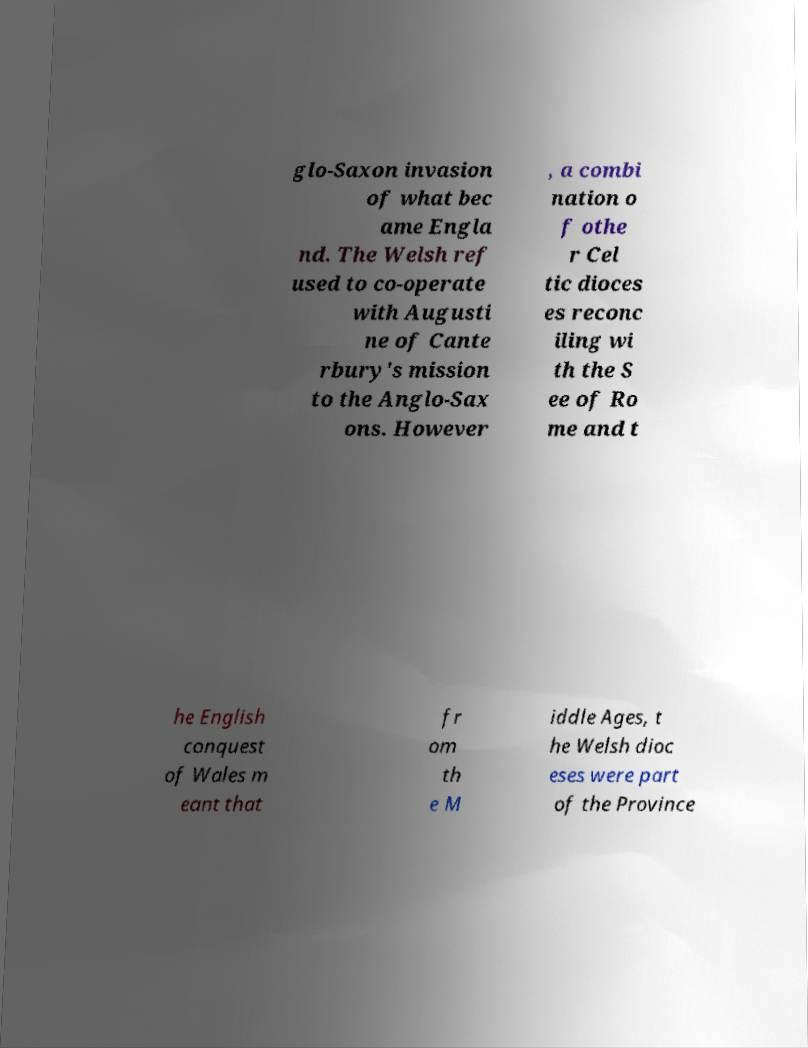Could you extract and type out the text from this image? glo-Saxon invasion of what bec ame Engla nd. The Welsh ref used to co-operate with Augusti ne of Cante rbury's mission to the Anglo-Sax ons. However , a combi nation o f othe r Cel tic dioces es reconc iling wi th the S ee of Ro me and t he English conquest of Wales m eant that fr om th e M iddle Ages, t he Welsh dioc eses were part of the Province 